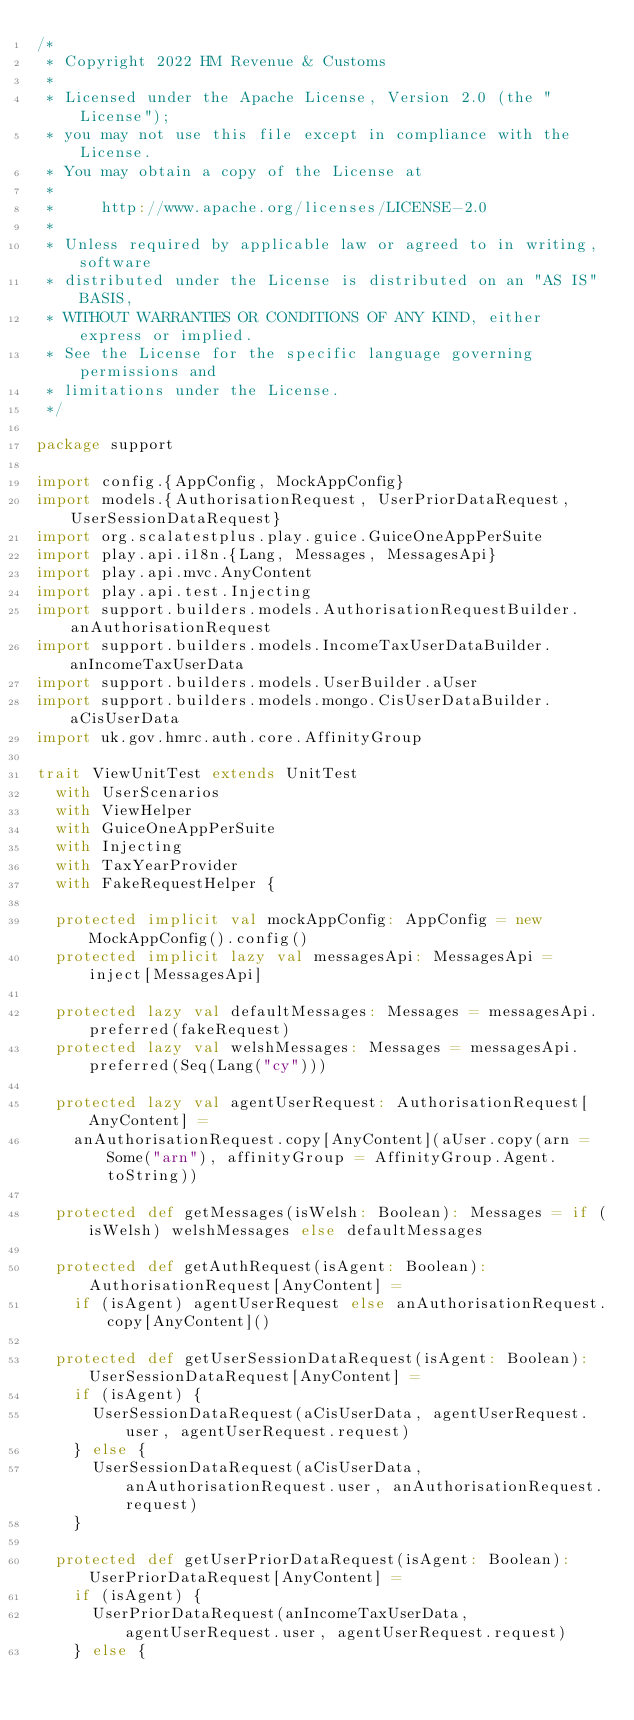<code> <loc_0><loc_0><loc_500><loc_500><_Scala_>/*
 * Copyright 2022 HM Revenue & Customs
 *
 * Licensed under the Apache License, Version 2.0 (the "License");
 * you may not use this file except in compliance with the License.
 * You may obtain a copy of the License at
 *
 *     http://www.apache.org/licenses/LICENSE-2.0
 *
 * Unless required by applicable law or agreed to in writing, software
 * distributed under the License is distributed on an "AS IS" BASIS,
 * WITHOUT WARRANTIES OR CONDITIONS OF ANY KIND, either express or implied.
 * See the License for the specific language governing permissions and
 * limitations under the License.
 */

package support

import config.{AppConfig, MockAppConfig}
import models.{AuthorisationRequest, UserPriorDataRequest, UserSessionDataRequest}
import org.scalatestplus.play.guice.GuiceOneAppPerSuite
import play.api.i18n.{Lang, Messages, MessagesApi}
import play.api.mvc.AnyContent
import play.api.test.Injecting
import support.builders.models.AuthorisationRequestBuilder.anAuthorisationRequest
import support.builders.models.IncomeTaxUserDataBuilder.anIncomeTaxUserData
import support.builders.models.UserBuilder.aUser
import support.builders.models.mongo.CisUserDataBuilder.aCisUserData
import uk.gov.hmrc.auth.core.AffinityGroup

trait ViewUnitTest extends UnitTest
  with UserScenarios
  with ViewHelper
  with GuiceOneAppPerSuite
  with Injecting
  with TaxYearProvider
  with FakeRequestHelper {

  protected implicit val mockAppConfig: AppConfig = new MockAppConfig().config()
  protected implicit lazy val messagesApi: MessagesApi = inject[MessagesApi]

  protected lazy val defaultMessages: Messages = messagesApi.preferred(fakeRequest)
  protected lazy val welshMessages: Messages = messagesApi.preferred(Seq(Lang("cy")))

  protected lazy val agentUserRequest: AuthorisationRequest[AnyContent] =
    anAuthorisationRequest.copy[AnyContent](aUser.copy(arn = Some("arn"), affinityGroup = AffinityGroup.Agent.toString))

  protected def getMessages(isWelsh: Boolean): Messages = if (isWelsh) welshMessages else defaultMessages

  protected def getAuthRequest(isAgent: Boolean): AuthorisationRequest[AnyContent] =
    if (isAgent) agentUserRequest else anAuthorisationRequest.copy[AnyContent]()

  protected def getUserSessionDataRequest(isAgent: Boolean): UserSessionDataRequest[AnyContent] =
    if (isAgent) {
      UserSessionDataRequest(aCisUserData, agentUserRequest.user, agentUserRequest.request)
    } else {
      UserSessionDataRequest(aCisUserData, anAuthorisationRequest.user, anAuthorisationRequest.request)
    }

  protected def getUserPriorDataRequest(isAgent: Boolean): UserPriorDataRequest[AnyContent] =
    if (isAgent) {
      UserPriorDataRequest(anIncomeTaxUserData, agentUserRequest.user, agentUserRequest.request)
    } else {</code> 